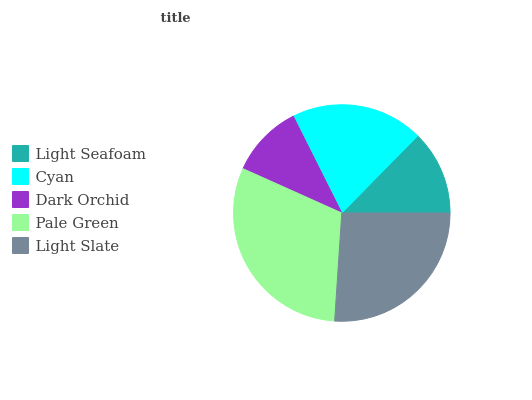Is Dark Orchid the minimum?
Answer yes or no. Yes. Is Pale Green the maximum?
Answer yes or no. Yes. Is Cyan the minimum?
Answer yes or no. No. Is Cyan the maximum?
Answer yes or no. No. Is Cyan greater than Light Seafoam?
Answer yes or no. Yes. Is Light Seafoam less than Cyan?
Answer yes or no. Yes. Is Light Seafoam greater than Cyan?
Answer yes or no. No. Is Cyan less than Light Seafoam?
Answer yes or no. No. Is Cyan the high median?
Answer yes or no. Yes. Is Cyan the low median?
Answer yes or no. Yes. Is Light Slate the high median?
Answer yes or no. No. Is Pale Green the low median?
Answer yes or no. No. 